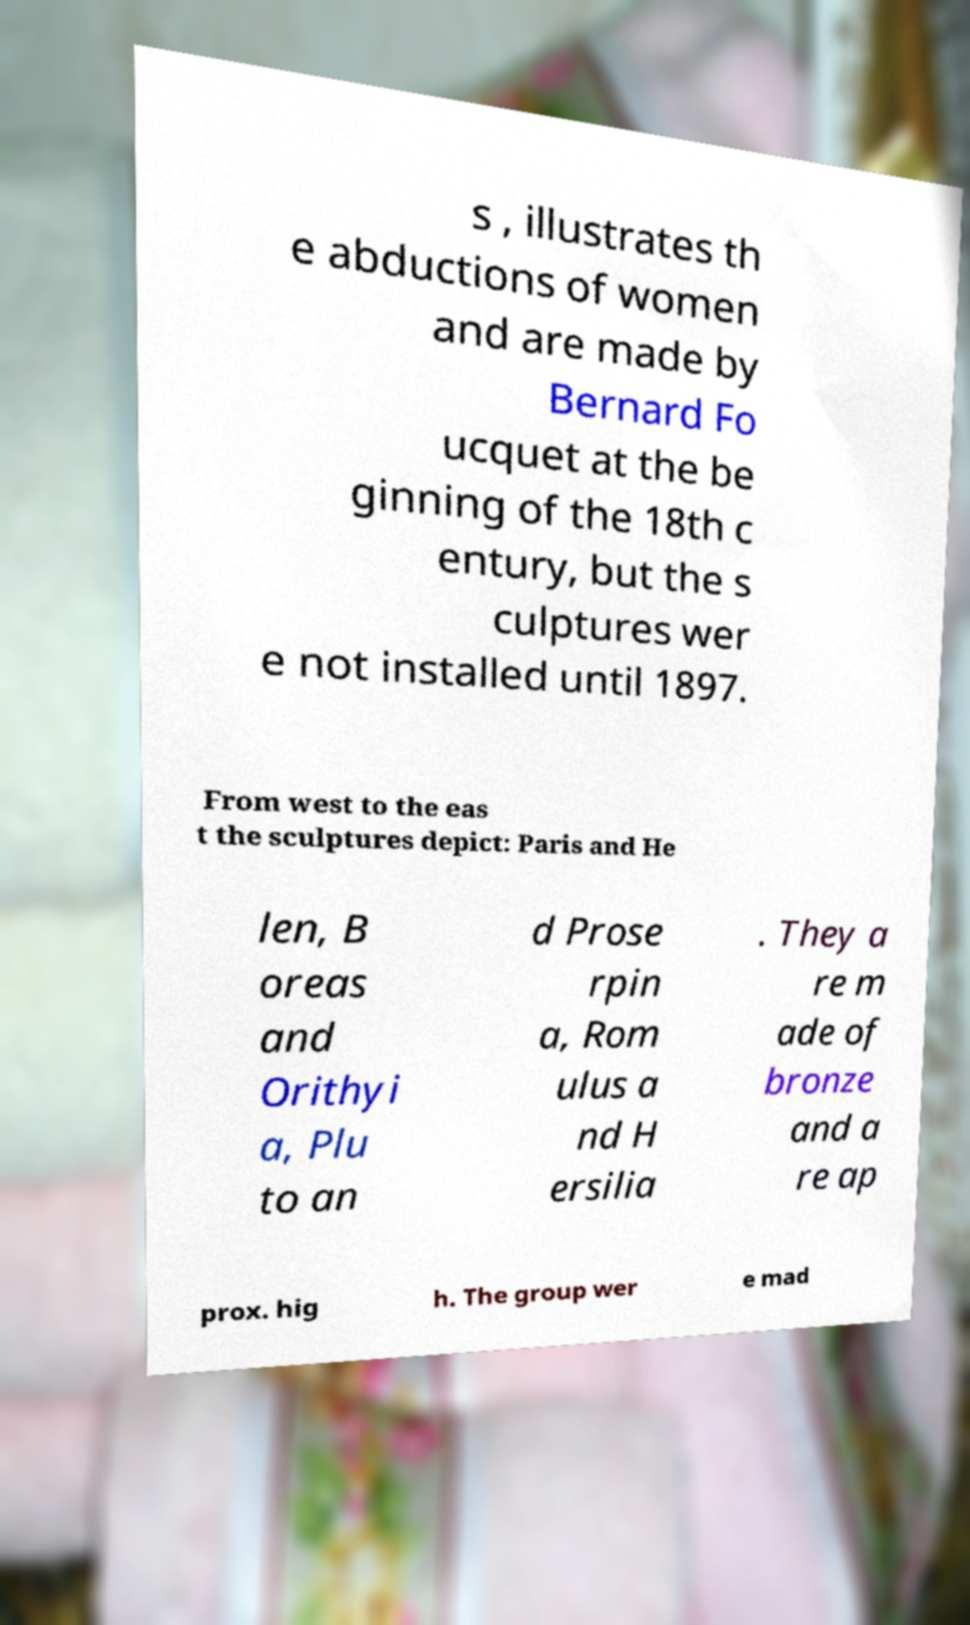For documentation purposes, I need the text within this image transcribed. Could you provide that? s , illustrates th e abductions of women and are made by Bernard Fo ucquet at the be ginning of the 18th c entury, but the s culptures wer e not installed until 1897. From west to the eas t the sculptures depict: Paris and He len, B oreas and Orithyi a, Plu to an d Prose rpin a, Rom ulus a nd H ersilia . They a re m ade of bronze and a re ap prox. hig h. The group wer e mad 